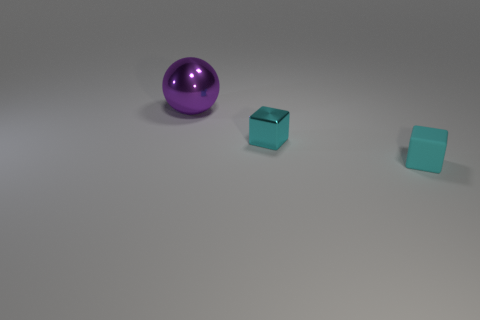Subtract all blue spheres. Subtract all purple cylinders. How many spheres are left? 1 Add 2 small cubes. How many objects exist? 5 Subtract all balls. How many objects are left? 2 Subtract 0 green spheres. How many objects are left? 3 Subtract all tiny red cubes. Subtract all purple spheres. How many objects are left? 2 Add 2 cyan cubes. How many cyan cubes are left? 4 Add 2 big purple objects. How many big purple objects exist? 3 